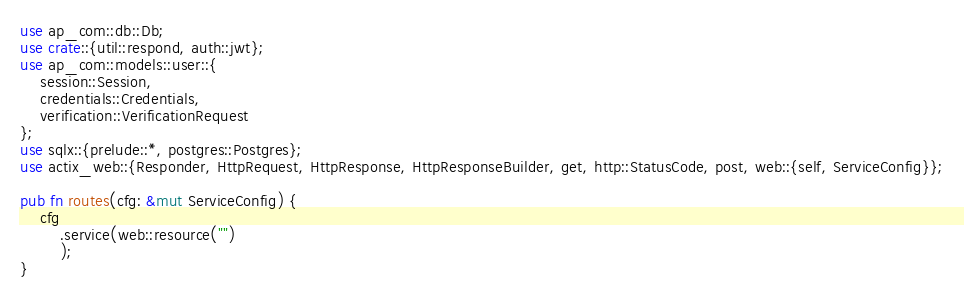Convert code to text. <code><loc_0><loc_0><loc_500><loc_500><_Rust_>use ap_com::db::Db;
use crate::{util::respond, auth::jwt};
use ap_com::models::user::{
    session::Session,
    credentials::Credentials,
    verification::VerificationRequest
};
use sqlx::{prelude::*, postgres::Postgres};
use actix_web::{Responder, HttpRequest, HttpResponse, HttpResponseBuilder, get, http::StatusCode, post, web::{self, ServiceConfig}};

pub fn routes(cfg: &mut ServiceConfig) {
    cfg
        .service(web::resource("")
        );
}

</code> 